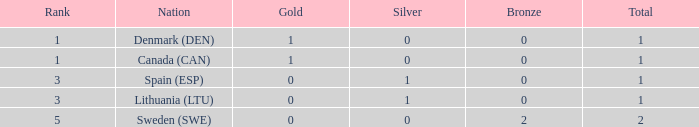What is the rank when there is 0 gold, the total is more than 1, and silver is more than 0? None. 